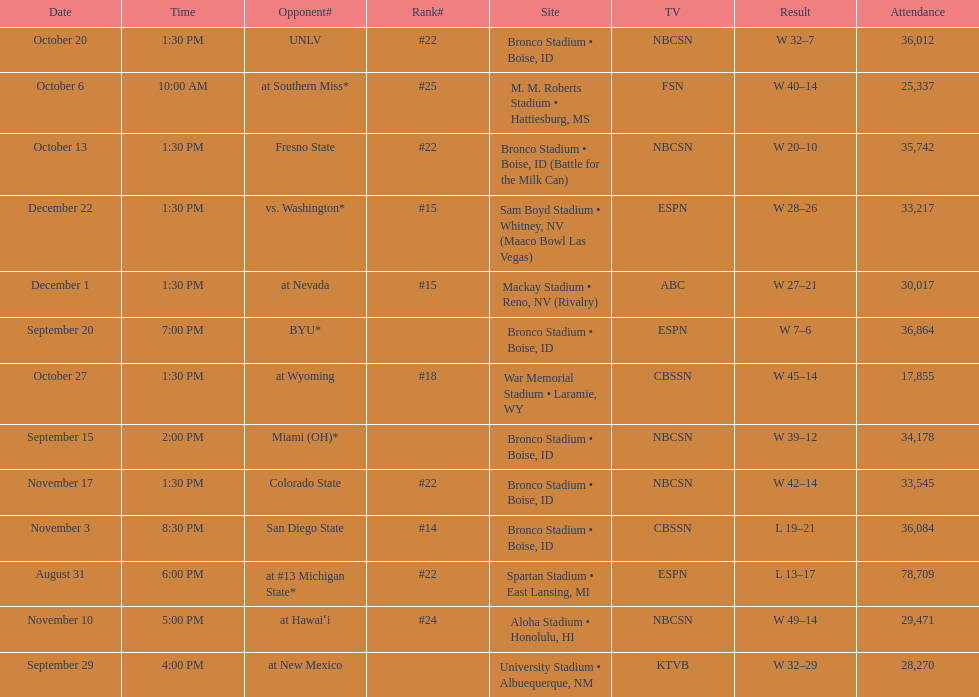Opponent broncos faced next after unlv Wyoming. 